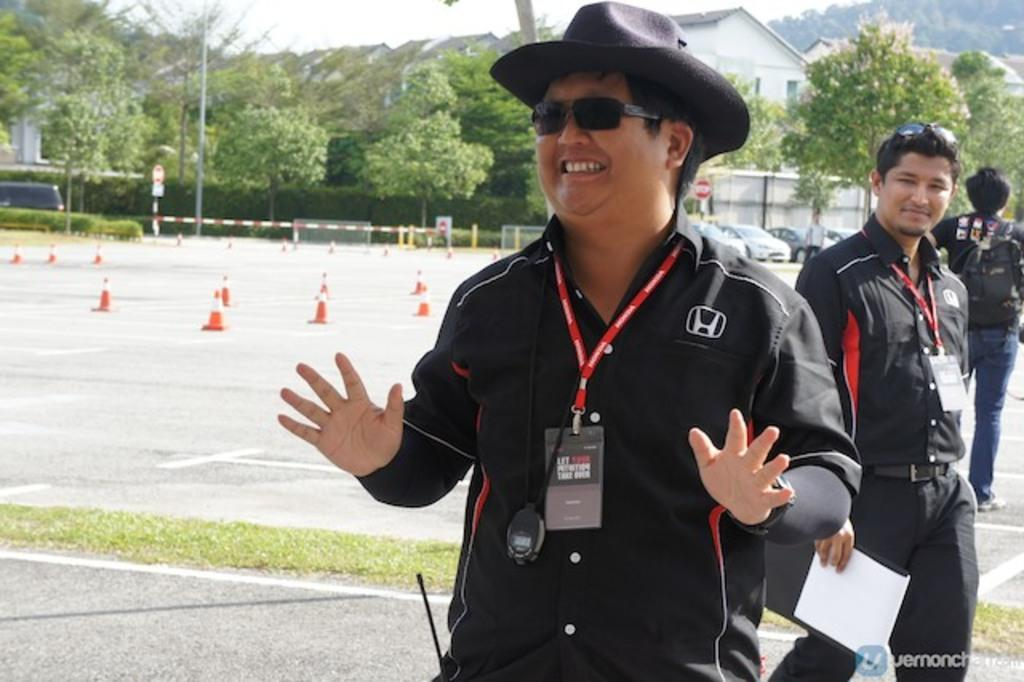How many people are on the right side of the image? There are three persons on the right side of the image. What can be seen in the background of the image? There are trees, cars, and buildings in the background of the image. What is visible at the top of the image? The sky is visible at the top of the image. What type of division can be seen between the trees and the cars in the image? There is no division between the trees and the cars in the image; they are simply different elements in the background. Can you hear the people on the right side of the image laughing in the image? The image is silent, and there is no indication of laughter or any sound. 